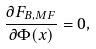<formula> <loc_0><loc_0><loc_500><loc_500>\frac { \partial F _ { B , M F } } { \partial \Phi ( x ) } = 0 ,</formula> 